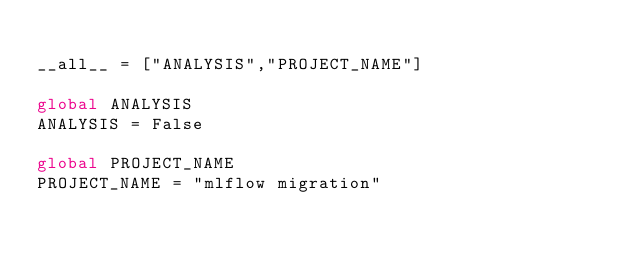Convert code to text. <code><loc_0><loc_0><loc_500><loc_500><_Python_>
__all__ = ["ANALYSIS","PROJECT_NAME"]

global ANALYSIS
ANALYSIS = False

global PROJECT_NAME
PROJECT_NAME = "mlflow migration"</code> 